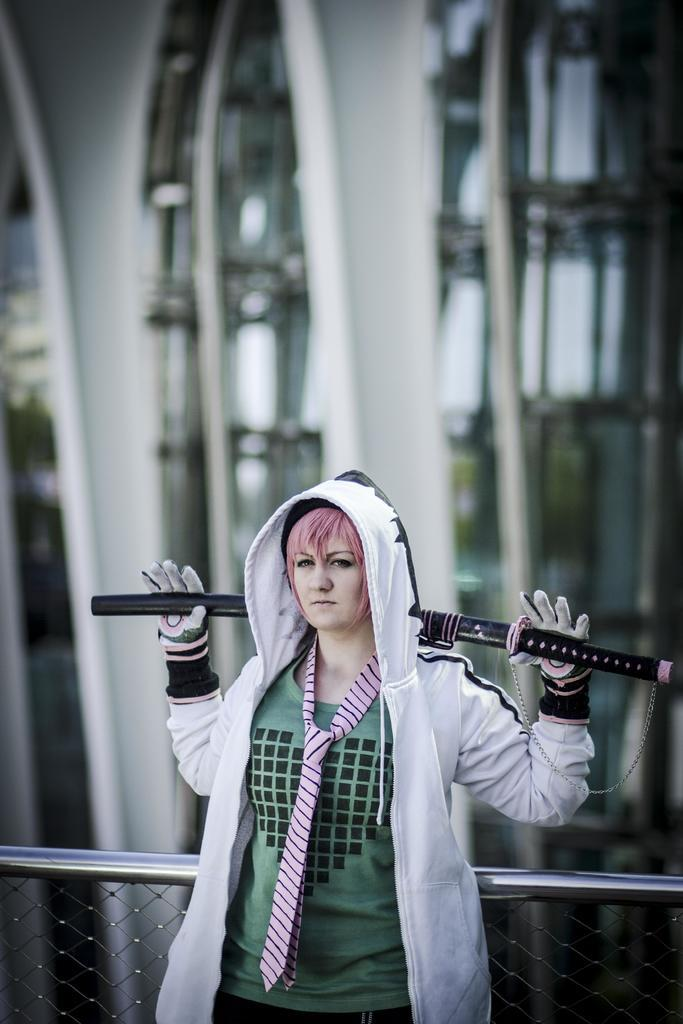Who is present in the image? There is a woman in the image. What is the woman wearing? The woman is wearing a jacket. What is the woman doing in the image? The woman is standing and holding a sword. What can be seen in the background of the image? There is a fence and a building in the background of the image. What type of glue is the woman using to attach the cow to the toad in the image? There is no glue, cow, or toad present in the image. 